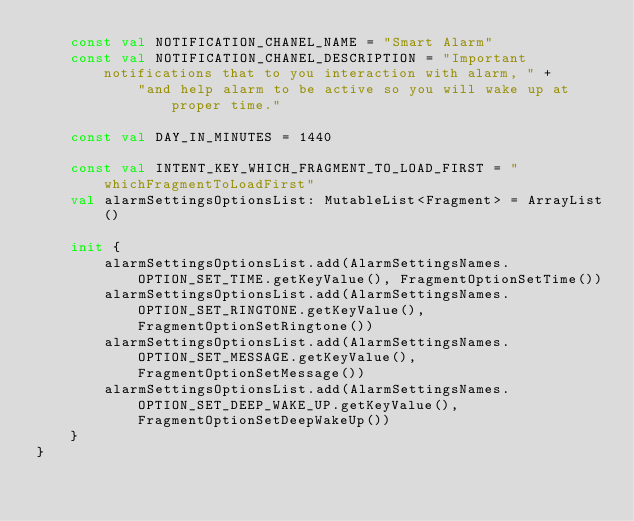Convert code to text. <code><loc_0><loc_0><loc_500><loc_500><_Kotlin_>    const val NOTIFICATION_CHANEL_NAME = "Smart Alarm"
    const val NOTIFICATION_CHANEL_DESCRIPTION = "Important notifications that to you interaction with alarm, " +
            "and help alarm to be active so you will wake up at proper time."

    const val DAY_IN_MINUTES = 1440

    const val INTENT_KEY_WHICH_FRAGMENT_TO_LOAD_FIRST = "whichFragmentToLoadFirst"
    val alarmSettingsOptionsList: MutableList<Fragment> = ArrayList()

    init {
        alarmSettingsOptionsList.add(AlarmSettingsNames.OPTION_SET_TIME.getKeyValue(), FragmentOptionSetTime())
        alarmSettingsOptionsList.add(AlarmSettingsNames.OPTION_SET_RINGTONE.getKeyValue(), FragmentOptionSetRingtone())
        alarmSettingsOptionsList.add(AlarmSettingsNames.OPTION_SET_MESSAGE.getKeyValue(), FragmentOptionSetMessage())
        alarmSettingsOptionsList.add(AlarmSettingsNames.OPTION_SET_DEEP_WAKE_UP.getKeyValue(), FragmentOptionSetDeepWakeUp())
    }
}

</code> 